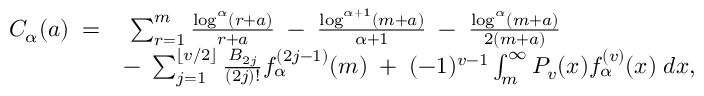Convert formula to latex. <formula><loc_0><loc_0><loc_500><loc_500>\begin{array} { r l } { C _ { \alpha } ( a ) \, = } & { \, \sum _ { r = 1 } ^ { m } \frac { \log ^ { \alpha } ( r + a ) } { r + a } \, - \, \frac { \log ^ { \alpha + 1 } ( m + a ) } { \alpha + 1 } \, - \, \frac { \log ^ { \alpha } ( m + a ) } { 2 ( m + a ) } } \\ & { - \, \sum _ { j = 1 } ^ { \lfloor v / 2 \rfloor } \frac { B _ { 2 j } } { ( 2 j ) ! } f _ { \alpha } ^ { ( 2 j - 1 ) } ( m ) \, + \, ( - 1 ) ^ { v - 1 } \int _ { m } ^ { \infty } P _ { v } ( x ) f _ { \alpha } ^ { ( v ) } ( x ) \, d x , } \end{array}</formula> 